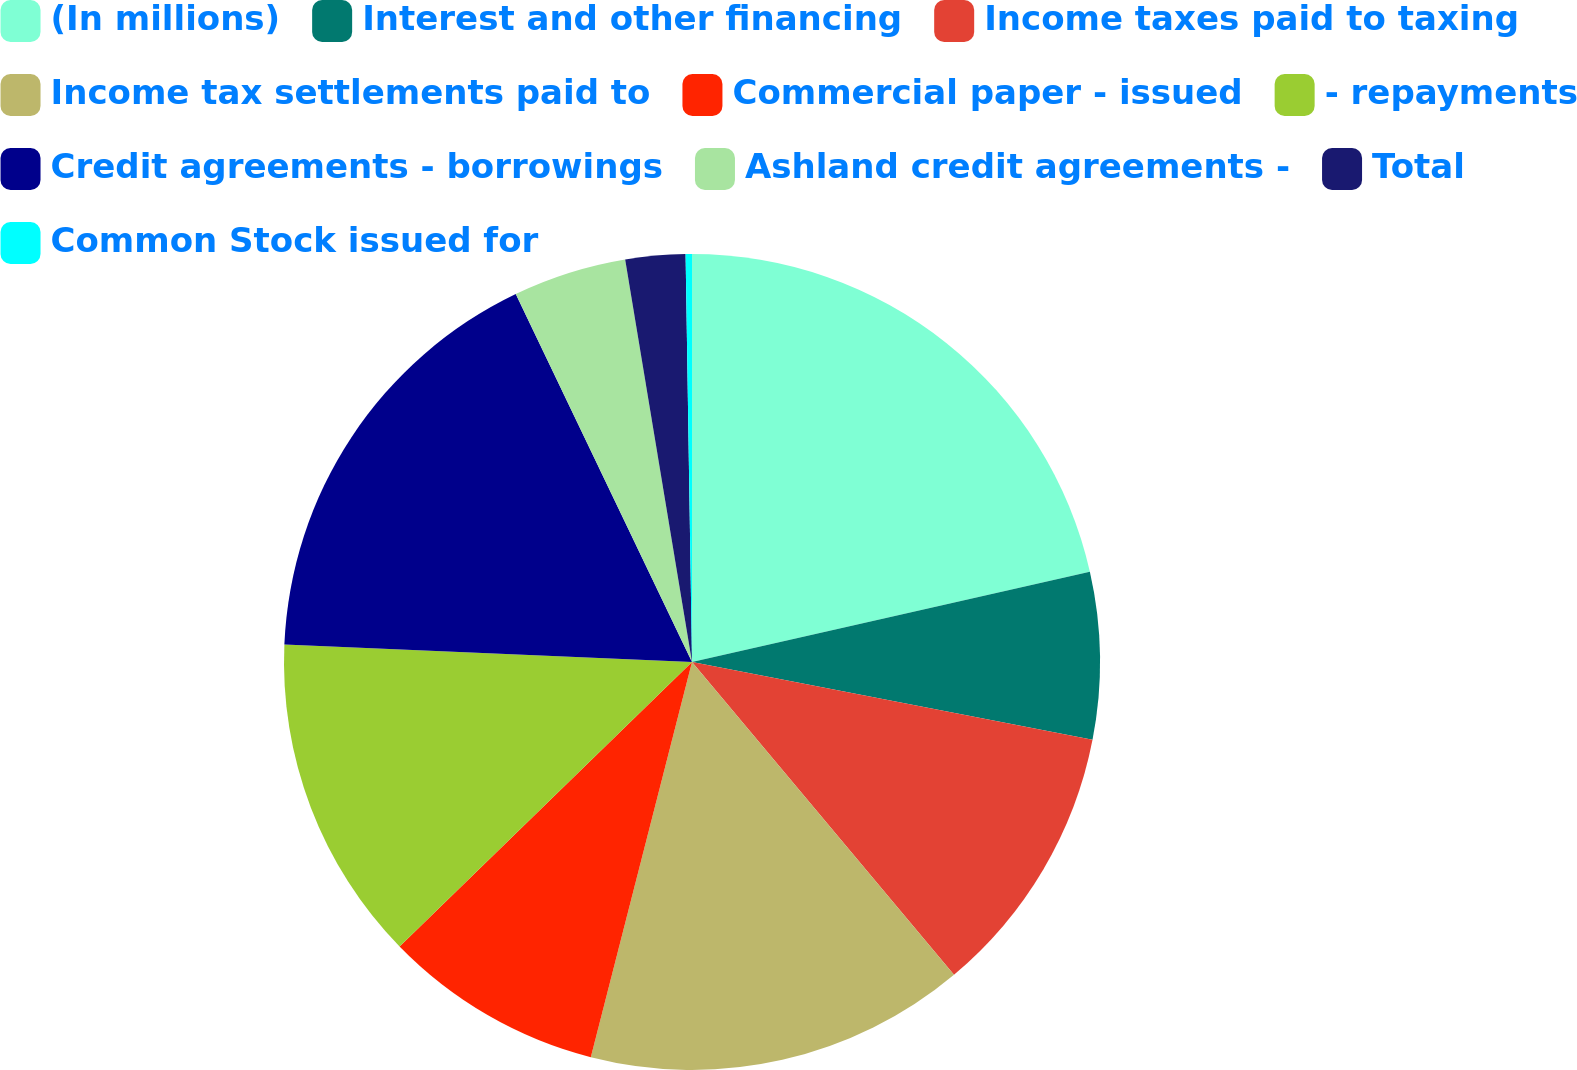Convert chart to OTSL. <chart><loc_0><loc_0><loc_500><loc_500><pie_chart><fcel>(In millions)<fcel>Interest and other financing<fcel>Income taxes paid to taxing<fcel>Income tax settlements paid to<fcel>Commercial paper - issued<fcel>- repayments<fcel>Credit agreements - borrowings<fcel>Ashland credit agreements -<fcel>Total<fcel>Common Stock issued for<nl><fcel>21.45%<fcel>6.61%<fcel>10.85%<fcel>15.09%<fcel>8.73%<fcel>12.97%<fcel>17.21%<fcel>4.49%<fcel>2.37%<fcel>0.25%<nl></chart> 